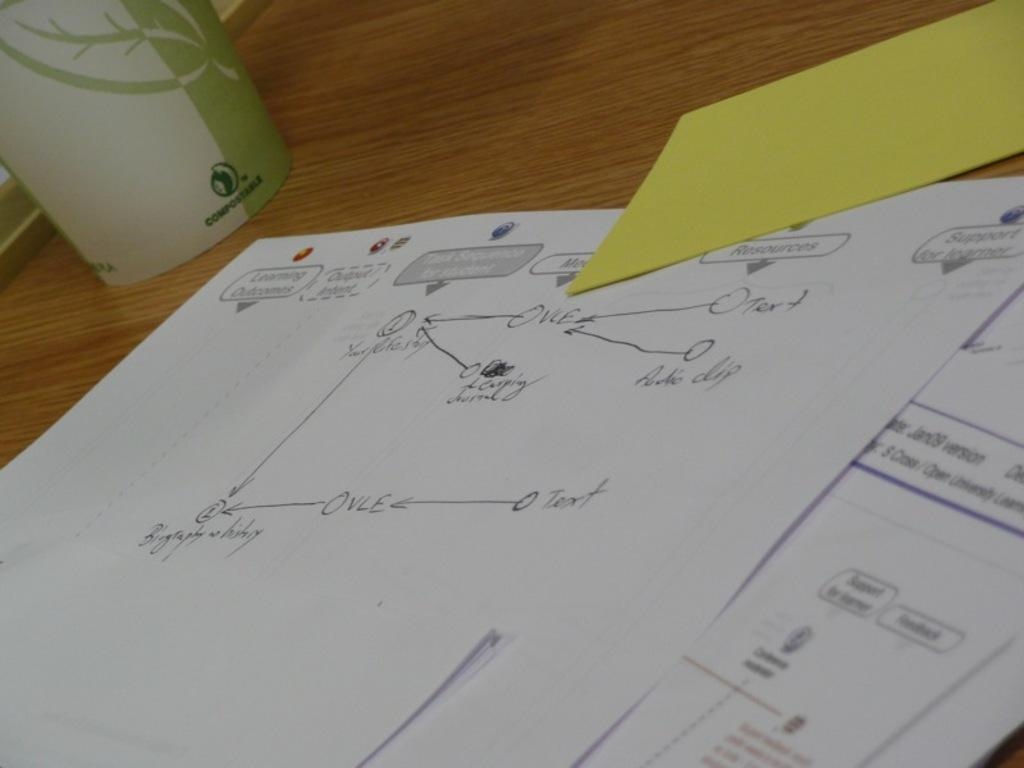<image>
Write a terse but informative summary of the picture. A piece of paper has a diagram with OVLE on it. 